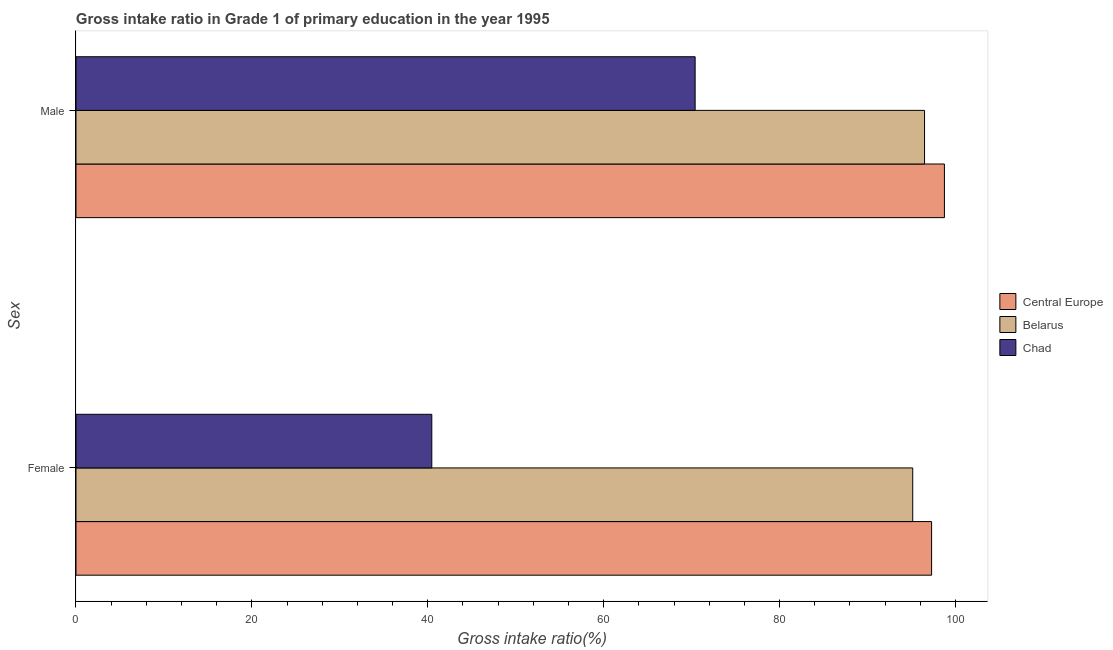How many different coloured bars are there?
Provide a short and direct response. 3. How many groups of bars are there?
Make the answer very short. 2. How many bars are there on the 2nd tick from the top?
Give a very brief answer. 3. What is the label of the 1st group of bars from the top?
Keep it short and to the point. Male. What is the gross intake ratio(female) in Chad?
Offer a terse response. 40.45. Across all countries, what is the maximum gross intake ratio(female)?
Provide a succinct answer. 97.28. Across all countries, what is the minimum gross intake ratio(female)?
Give a very brief answer. 40.45. In which country was the gross intake ratio(male) maximum?
Your response must be concise. Central Europe. In which country was the gross intake ratio(male) minimum?
Your answer should be very brief. Chad. What is the total gross intake ratio(male) in the graph?
Your response must be concise. 265.61. What is the difference between the gross intake ratio(female) in Belarus and that in Chad?
Provide a succinct answer. 54.68. What is the difference between the gross intake ratio(male) in Belarus and the gross intake ratio(female) in Chad?
Ensure brevity in your answer.  56.02. What is the average gross intake ratio(female) per country?
Offer a terse response. 77.62. What is the difference between the gross intake ratio(female) and gross intake ratio(male) in Chad?
Your answer should be compact. -29.94. What is the ratio of the gross intake ratio(female) in Belarus to that in Central Europe?
Make the answer very short. 0.98. What does the 3rd bar from the top in Female represents?
Provide a short and direct response. Central Europe. What does the 2nd bar from the bottom in Male represents?
Your answer should be compact. Belarus. How many bars are there?
Provide a succinct answer. 6. How many countries are there in the graph?
Your answer should be very brief. 3. What is the difference between two consecutive major ticks on the X-axis?
Offer a very short reply. 20. Are the values on the major ticks of X-axis written in scientific E-notation?
Make the answer very short. No. How many legend labels are there?
Make the answer very short. 3. How are the legend labels stacked?
Ensure brevity in your answer.  Vertical. What is the title of the graph?
Your answer should be compact. Gross intake ratio in Grade 1 of primary education in the year 1995. Does "Turkey" appear as one of the legend labels in the graph?
Offer a very short reply. No. What is the label or title of the X-axis?
Give a very brief answer. Gross intake ratio(%). What is the label or title of the Y-axis?
Provide a succinct answer. Sex. What is the Gross intake ratio(%) of Central Europe in Female?
Ensure brevity in your answer.  97.28. What is the Gross intake ratio(%) in Belarus in Female?
Your response must be concise. 95.13. What is the Gross intake ratio(%) in Chad in Female?
Your answer should be very brief. 40.45. What is the Gross intake ratio(%) in Central Europe in Male?
Ensure brevity in your answer.  98.74. What is the Gross intake ratio(%) of Belarus in Male?
Provide a short and direct response. 96.48. What is the Gross intake ratio(%) of Chad in Male?
Provide a short and direct response. 70.39. Across all Sex, what is the maximum Gross intake ratio(%) in Central Europe?
Keep it short and to the point. 98.74. Across all Sex, what is the maximum Gross intake ratio(%) of Belarus?
Keep it short and to the point. 96.48. Across all Sex, what is the maximum Gross intake ratio(%) in Chad?
Ensure brevity in your answer.  70.39. Across all Sex, what is the minimum Gross intake ratio(%) of Central Europe?
Your answer should be very brief. 97.28. Across all Sex, what is the minimum Gross intake ratio(%) of Belarus?
Your response must be concise. 95.13. Across all Sex, what is the minimum Gross intake ratio(%) of Chad?
Your response must be concise. 40.45. What is the total Gross intake ratio(%) in Central Europe in the graph?
Give a very brief answer. 196.02. What is the total Gross intake ratio(%) in Belarus in the graph?
Offer a terse response. 191.61. What is the total Gross intake ratio(%) of Chad in the graph?
Offer a terse response. 110.85. What is the difference between the Gross intake ratio(%) in Central Europe in Female and that in Male?
Your response must be concise. -1.46. What is the difference between the Gross intake ratio(%) of Belarus in Female and that in Male?
Provide a short and direct response. -1.34. What is the difference between the Gross intake ratio(%) in Chad in Female and that in Male?
Your answer should be compact. -29.94. What is the difference between the Gross intake ratio(%) in Central Europe in Female and the Gross intake ratio(%) in Belarus in Male?
Make the answer very short. 0.8. What is the difference between the Gross intake ratio(%) of Central Europe in Female and the Gross intake ratio(%) of Chad in Male?
Your answer should be very brief. 26.88. What is the difference between the Gross intake ratio(%) of Belarus in Female and the Gross intake ratio(%) of Chad in Male?
Offer a very short reply. 24.74. What is the average Gross intake ratio(%) in Central Europe per Sex?
Make the answer very short. 98.01. What is the average Gross intake ratio(%) of Belarus per Sex?
Offer a terse response. 95.81. What is the average Gross intake ratio(%) in Chad per Sex?
Offer a very short reply. 55.42. What is the difference between the Gross intake ratio(%) of Central Europe and Gross intake ratio(%) of Belarus in Female?
Your answer should be very brief. 2.15. What is the difference between the Gross intake ratio(%) in Central Europe and Gross intake ratio(%) in Chad in Female?
Ensure brevity in your answer.  56.83. What is the difference between the Gross intake ratio(%) in Belarus and Gross intake ratio(%) in Chad in Female?
Offer a terse response. 54.68. What is the difference between the Gross intake ratio(%) of Central Europe and Gross intake ratio(%) of Belarus in Male?
Ensure brevity in your answer.  2.26. What is the difference between the Gross intake ratio(%) of Central Europe and Gross intake ratio(%) of Chad in Male?
Offer a very short reply. 28.34. What is the difference between the Gross intake ratio(%) of Belarus and Gross intake ratio(%) of Chad in Male?
Your answer should be very brief. 26.08. What is the ratio of the Gross intake ratio(%) in Central Europe in Female to that in Male?
Provide a succinct answer. 0.99. What is the ratio of the Gross intake ratio(%) in Belarus in Female to that in Male?
Provide a short and direct response. 0.99. What is the ratio of the Gross intake ratio(%) in Chad in Female to that in Male?
Keep it short and to the point. 0.57. What is the difference between the highest and the second highest Gross intake ratio(%) in Central Europe?
Your response must be concise. 1.46. What is the difference between the highest and the second highest Gross intake ratio(%) in Belarus?
Keep it short and to the point. 1.34. What is the difference between the highest and the second highest Gross intake ratio(%) of Chad?
Your response must be concise. 29.94. What is the difference between the highest and the lowest Gross intake ratio(%) of Central Europe?
Keep it short and to the point. 1.46. What is the difference between the highest and the lowest Gross intake ratio(%) in Belarus?
Give a very brief answer. 1.34. What is the difference between the highest and the lowest Gross intake ratio(%) in Chad?
Make the answer very short. 29.94. 